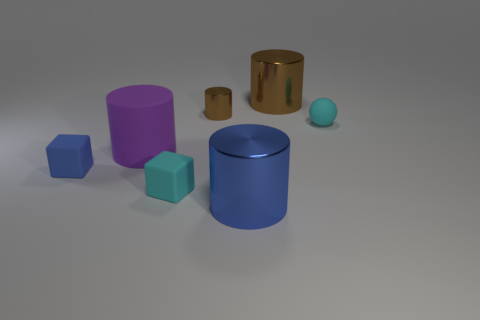Subtract all small cylinders. How many cylinders are left? 3 Add 2 big objects. How many objects exist? 9 Subtract all cyan cubes. How many cubes are left? 1 Subtract all cylinders. How many objects are left? 3 Subtract 1 balls. How many balls are left? 0 Add 2 small cyan matte balls. How many small cyan matte balls exist? 3 Subtract 0 yellow balls. How many objects are left? 7 Subtract all purple spheres. Subtract all cyan cylinders. How many spheres are left? 1 Subtract all yellow cubes. How many red balls are left? 0 Subtract all large blue things. Subtract all large things. How many objects are left? 3 